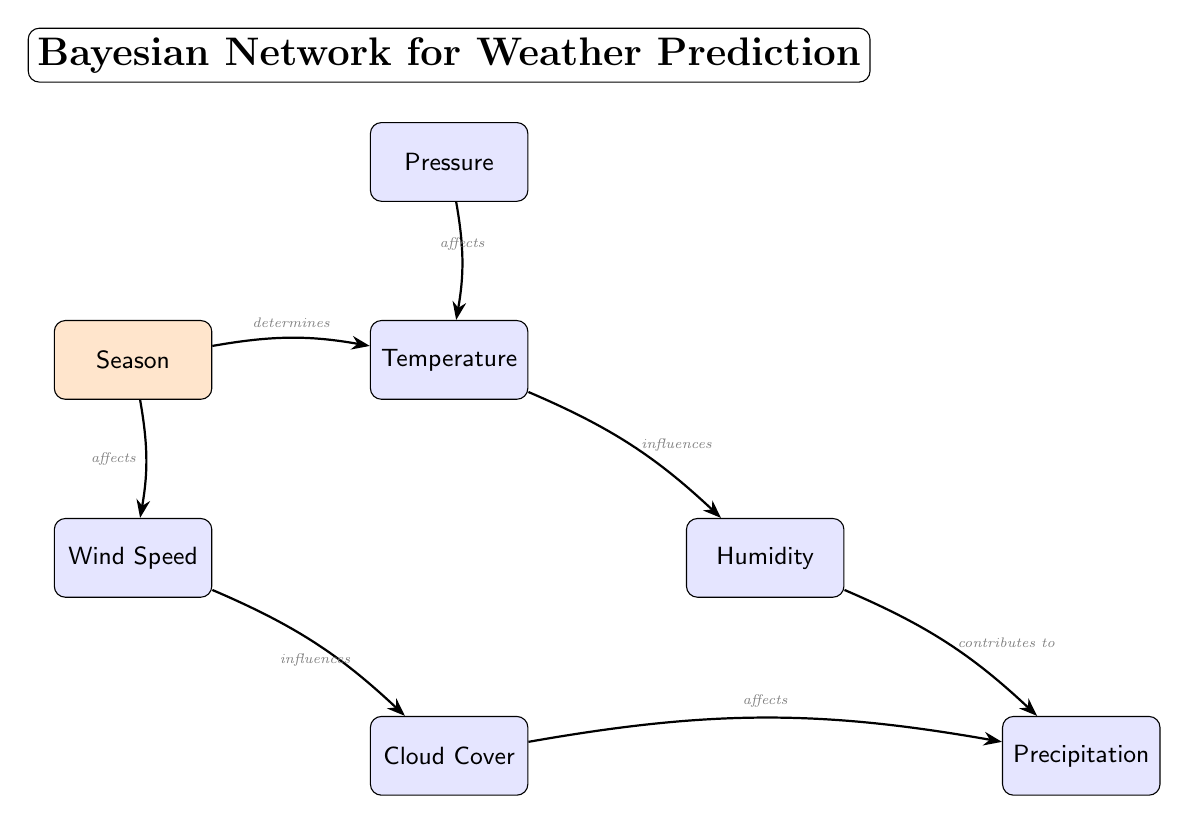What is the total number of nodes in the diagram? By counting the nodes visually represented in the diagram, we can identify seven distinct meteorological variables and one seasonal factor, which gives a total of eight nodes.
Answer: Eight Which node is affected by Pressure? The diagram indicates a direct arrow pointing from Pressure to Temperature, signifying that Pressure affects Temperature.
Answer: Temperature What does Humidity contribute to? There is an arrow from Humidity to Precipitation in the diagram, which indicates that Humidity contributes to the occurrence of Precipitation.
Answer: Precipitation How many directed edges are present in the diagram? By counting the arrows or directed edges that connect the nodes of the diagram, we find a total of six edges connecting the different meteorological variables and their dependencies.
Answer: Six Which two nodes show an influence relationship? The diagram shows an influence relationship between Temperature and Humidity, as represented by the directed arrow from Temperature to Humidity, indicating that Temperature influences Humidity.
Answer: Temperature and Humidity Which node determines Temperature? Following the directed edge labeled "determines," we can see that Season is the node that determines Temperature in the diagram.
Answer: Season What relationship exists between Wind Speed and Cloud Cover? The directed edge from Wind Speed to Cloud Cover indicates that Wind Speed influences Cloud Cover, illustrating a direct relationship between these two variables.
Answer: Influences What are the conditional dependencies depicted in the diagram? The diagram captures conditional dependencies among meteorological variables where Temperature is conditioned by Pressure and Season, Humidity is conditioned by Temperature, and Precipitation is conditioned by both Humidity and Cloud Cover.
Answer: Conditional dependencies among variables Which node has the most incoming edges? By analyzing the connections, we see that Precipitation has the most incoming edges, coming from both Humidity and Cloud Cover, indicating multiple dependencies.
Answer: Precipitation 